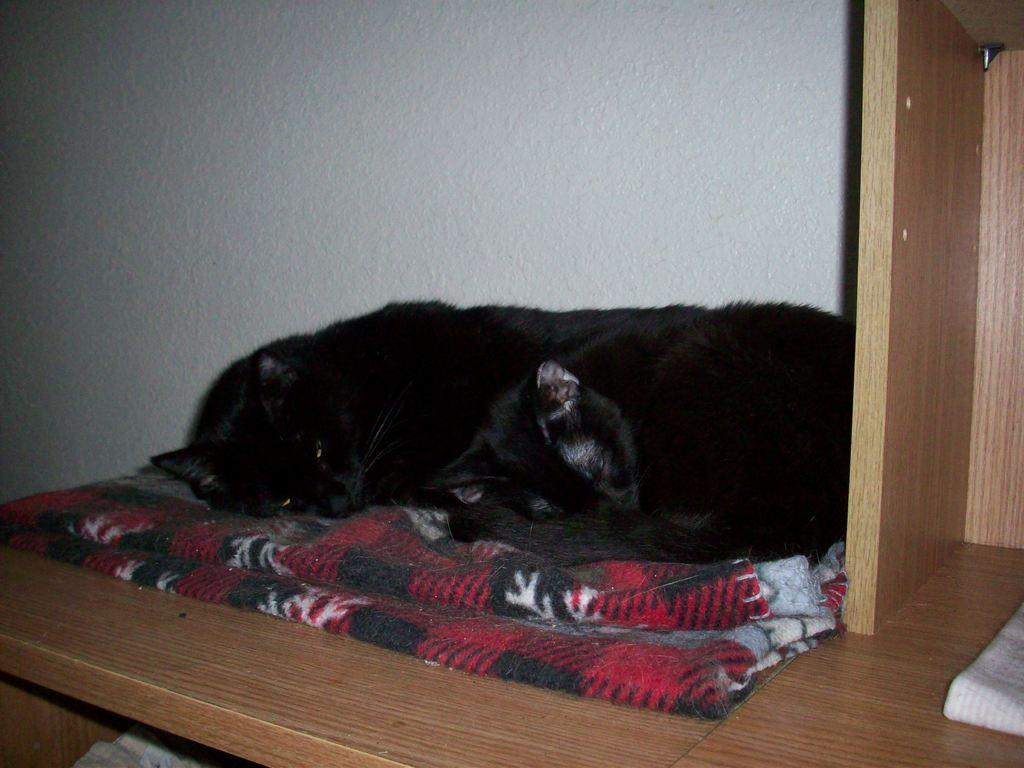What type of animal is in the image? There is a cat in the image. What color is the cat? The cat is black in color. What is the cat sitting on? The cat is on a cloth with red, white, and black colors. What can be seen behind the cat? There is a white wall in the background of the image. What type of surface is the cat sitting on? The cat is on a wooden surface. How many rabbits are visible in the image? There are no rabbits present in the image; it features a black cat on a cloth with red, white, and black colors. What type of property is being sold in the image? There is no property being sold in the image; it features a black cat on a cloth with red, white, and black colors. 